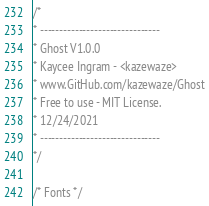Convert code to text. <code><loc_0><loc_0><loc_500><loc_500><_CSS_>/*
* -------------------------------
* Ghost V1.0.0
* Kaycee Ingram - <kazewaze>
* www.GitHub.com/kazewaze/Ghost
* Free to use - MIT License.
* 12/24/2021
* -------------------------------
*/

/* Fonts */</code> 